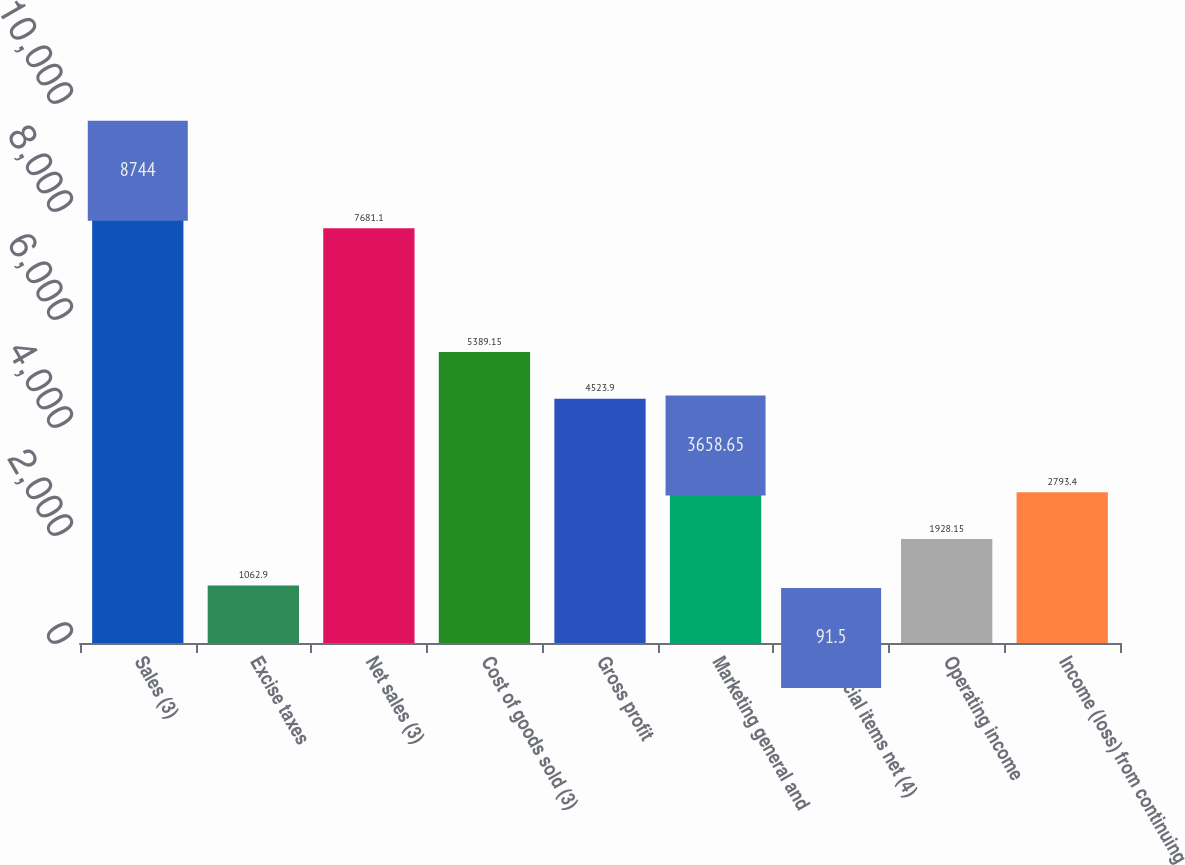Convert chart. <chart><loc_0><loc_0><loc_500><loc_500><bar_chart><fcel>Sales (3)<fcel>Excise taxes<fcel>Net sales (3)<fcel>Cost of goods sold (3)<fcel>Gross profit<fcel>Marketing general and<fcel>Special items net (4)<fcel>Operating income<fcel>Income (loss) from continuing<nl><fcel>8744<fcel>1062.9<fcel>7681.1<fcel>5389.15<fcel>4523.9<fcel>3658.65<fcel>91.5<fcel>1928.15<fcel>2793.4<nl></chart> 